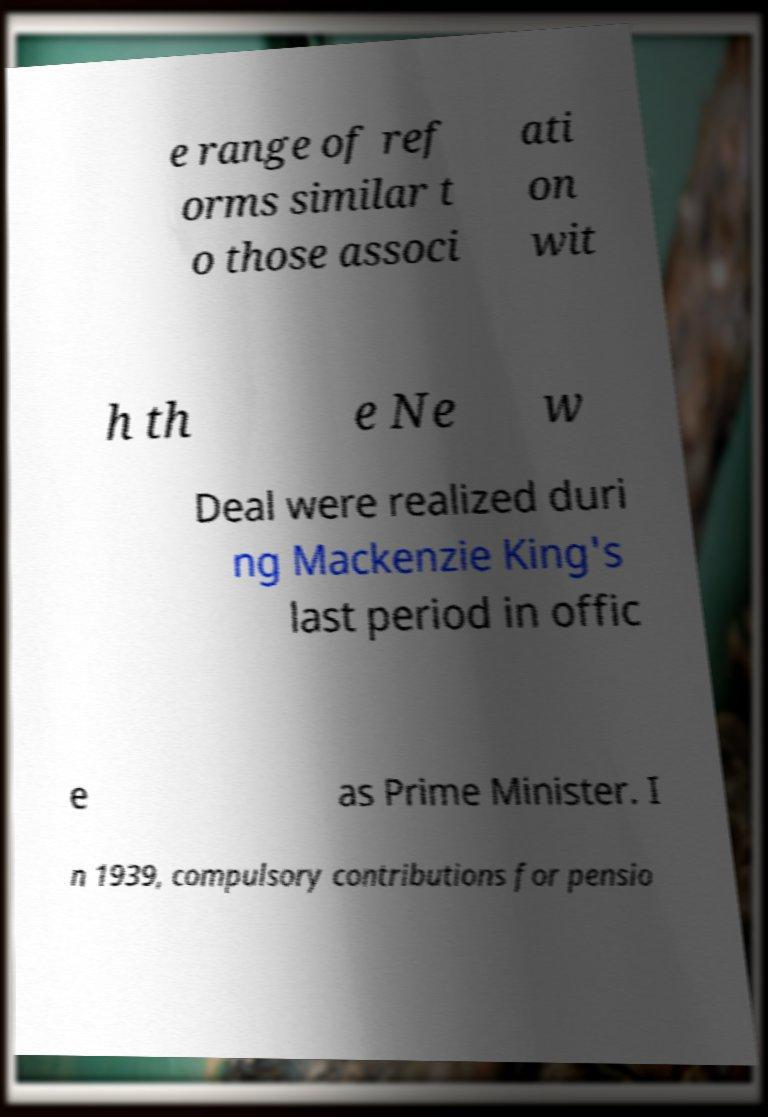Could you extract and type out the text from this image? e range of ref orms similar t o those associ ati on wit h th e Ne w Deal were realized duri ng Mackenzie King's last period in offic e as Prime Minister. I n 1939, compulsory contributions for pensio 